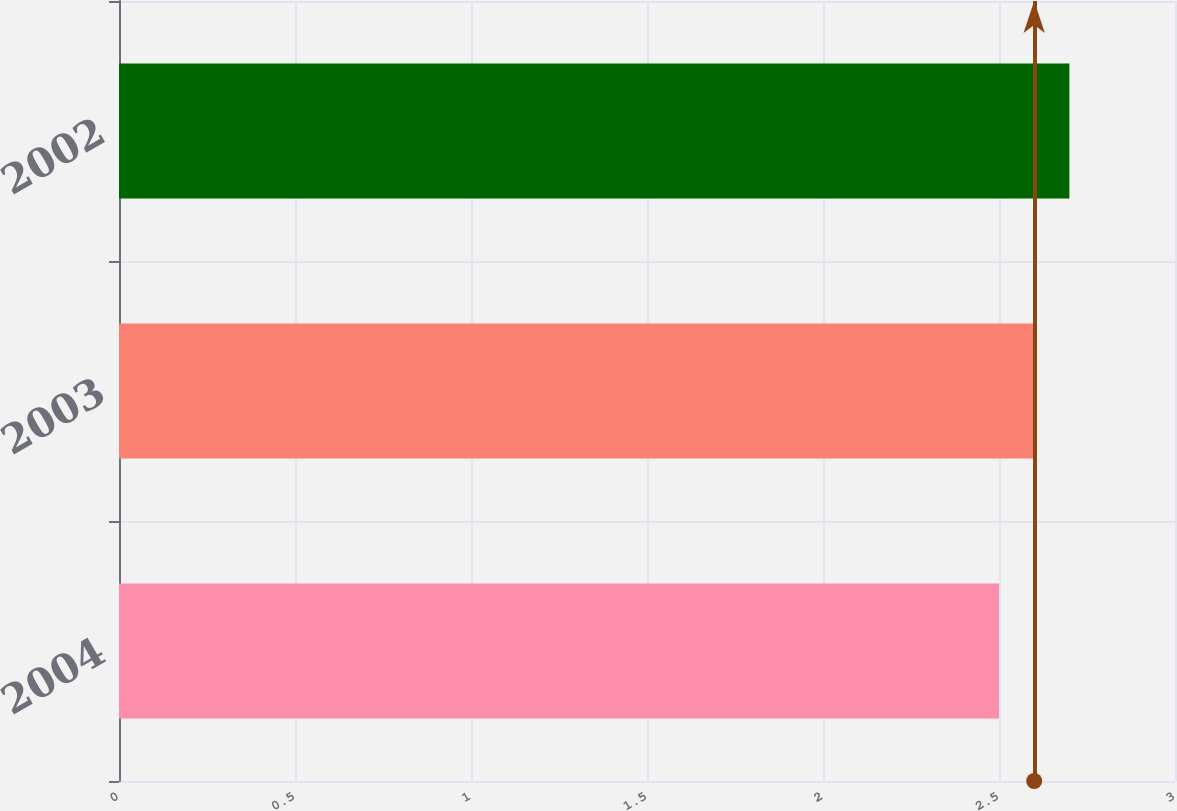Convert chart to OTSL. <chart><loc_0><loc_0><loc_500><loc_500><bar_chart><fcel>2004<fcel>2003<fcel>2002<nl><fcel>2.5<fcel>2.6<fcel>2.7<nl></chart> 